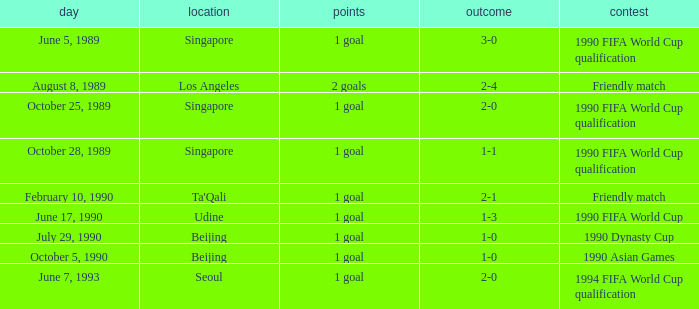What is the score of the match on October 5, 1990? 1 goal. 